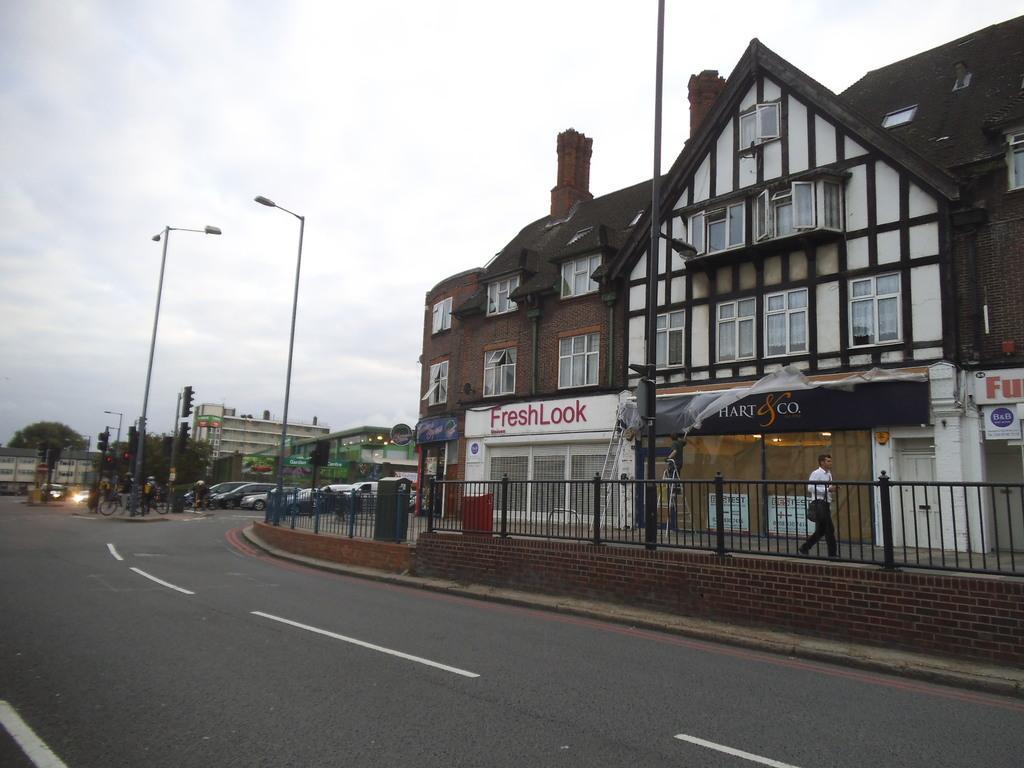How would you summarize this image in a sentence or two? In this picture we can see a person is walking on the path and on the left side of the person there is iron fence. Behind the person there are poles with lights and traffic signals and some people with their bicycles and behind the people there are some vehicles, buildings, trees and a sky. 